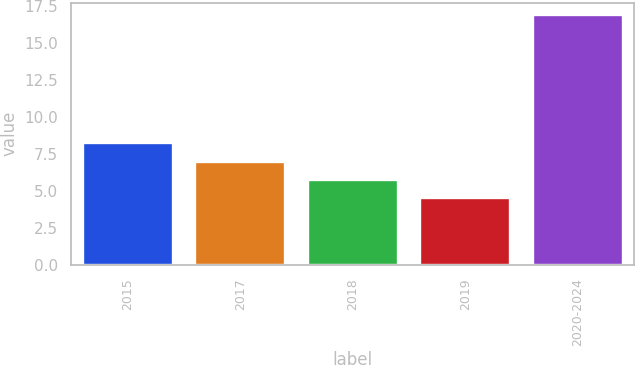Convert chart. <chart><loc_0><loc_0><loc_500><loc_500><bar_chart><fcel>2015<fcel>2017<fcel>2018<fcel>2019<fcel>2020-2024<nl><fcel>8.22<fcel>6.98<fcel>5.74<fcel>4.5<fcel>16.9<nl></chart> 